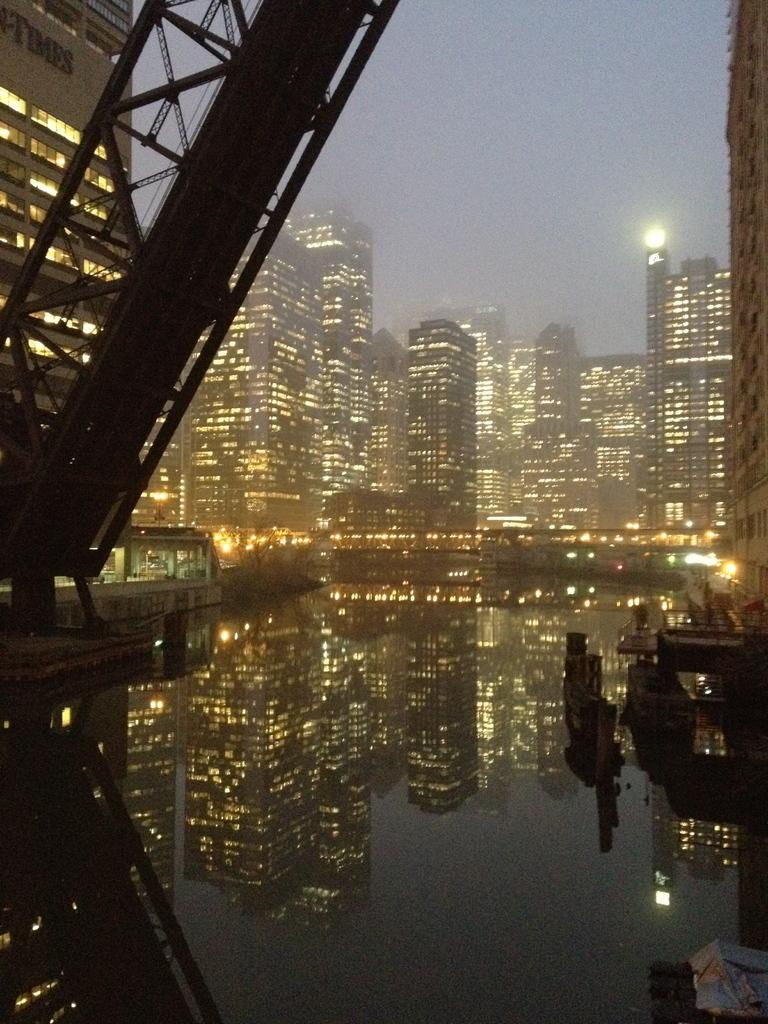What is the primary element visible in the image? There is water in the image. What type of structures can be seen in the image? There are buildings in the image. Are there any illuminated elements in the image? Yes, there are lights in the image. What else can be seen in the image besides the water and buildings? There are objects in the image. What is visible in the background of the image? The sky is visible in the background of the image. What type of jewel is being worn by the band in the image? There is no band or jewel present in the image. What type of church can be seen in the image? There is no church present in the image. 